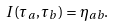Convert formula to latex. <formula><loc_0><loc_0><loc_500><loc_500>I ( \tau _ { a } , \tau _ { b } ) = \eta _ { a b } .</formula> 